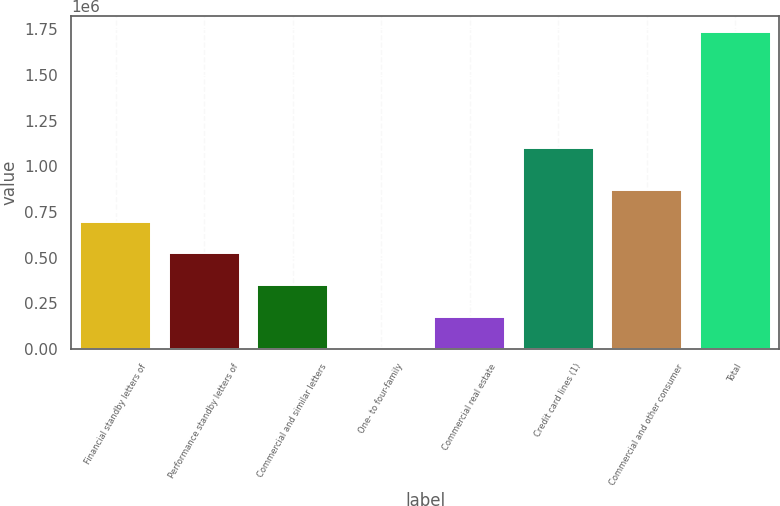Convert chart. <chart><loc_0><loc_0><loc_500><loc_500><bar_chart><fcel>Financial standby letters of<fcel>Performance standby letters of<fcel>Commercial and similar letters<fcel>One- to four-family<fcel>Commercial real estate<fcel>Credit card lines (1)<fcel>Commercial and other consumer<fcel>Total<nl><fcel>697180<fcel>524032<fcel>350884<fcel>4587<fcel>177735<fcel>1.10354e+06<fcel>870328<fcel>1.73607e+06<nl></chart> 